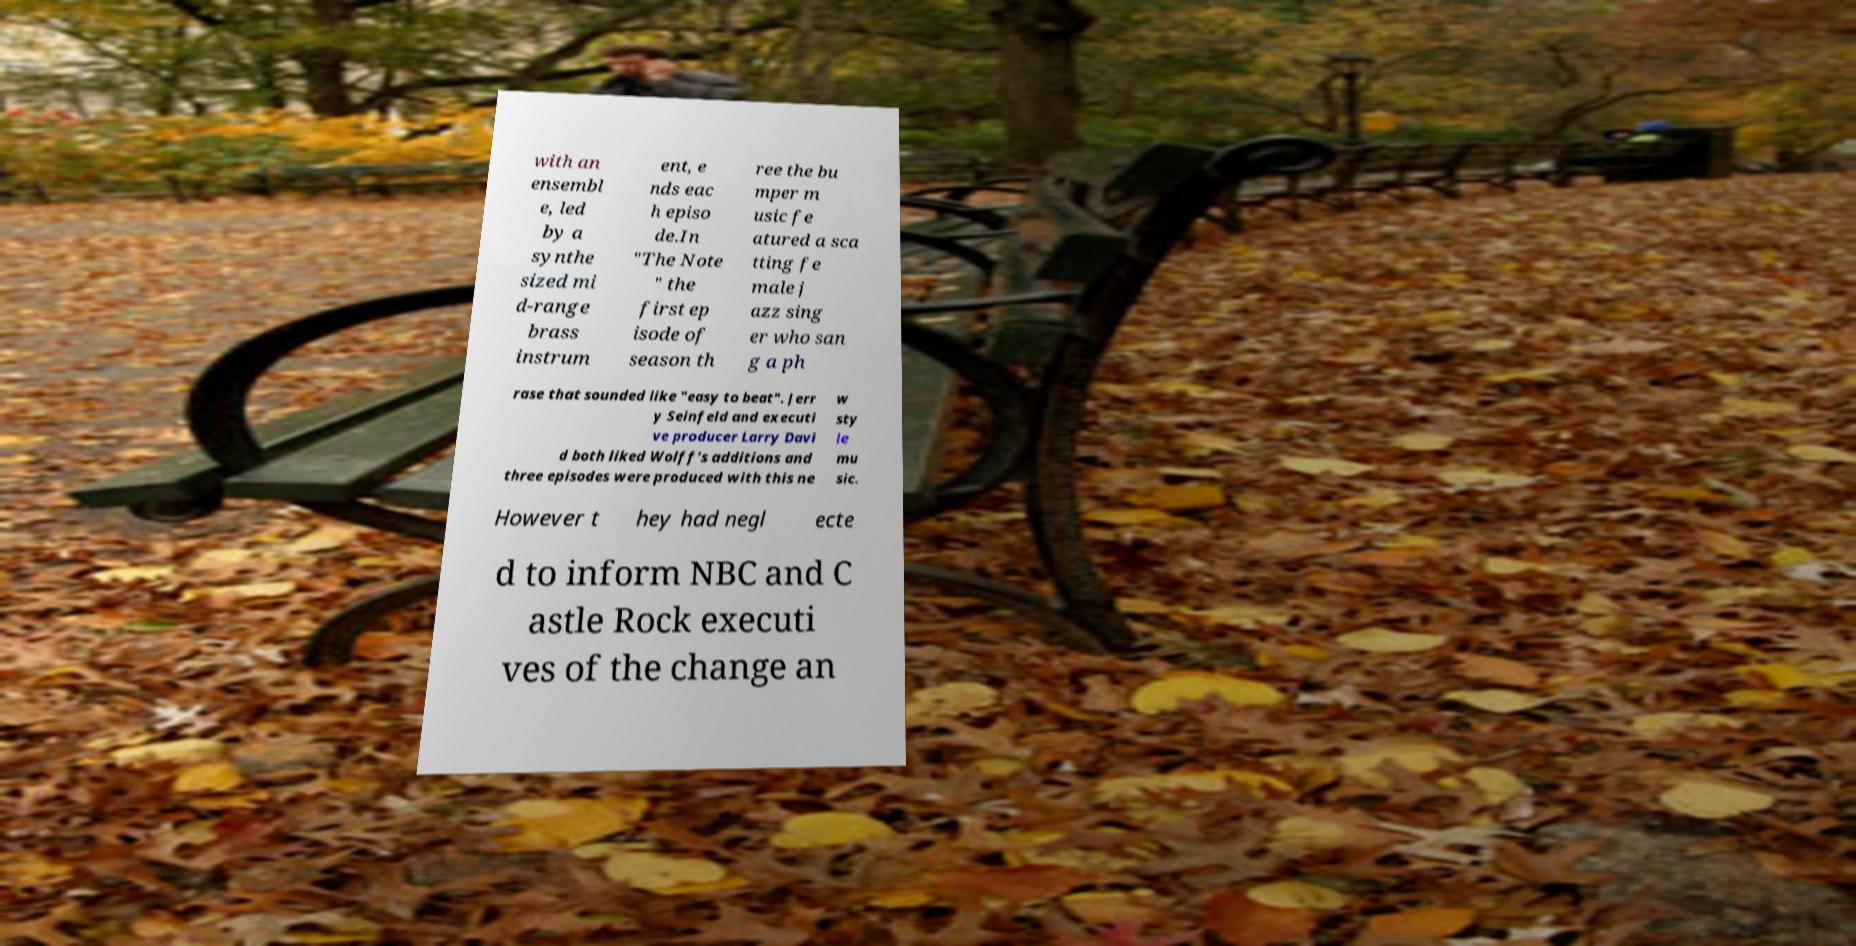There's text embedded in this image that I need extracted. Can you transcribe it verbatim? with an ensembl e, led by a synthe sized mi d-range brass instrum ent, e nds eac h episo de.In "The Note " the first ep isode of season th ree the bu mper m usic fe atured a sca tting fe male j azz sing er who san g a ph rase that sounded like "easy to beat". Jerr y Seinfeld and executi ve producer Larry Davi d both liked Wolff's additions and three episodes were produced with this ne w sty le mu sic. However t hey had negl ecte d to inform NBC and C astle Rock executi ves of the change an 